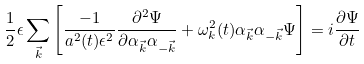<formula> <loc_0><loc_0><loc_500><loc_500>\frac { 1 } { 2 } \epsilon \sum _ { \vec { k } } { \left [ \frac { - 1 } { a ^ { 2 } ( t ) \epsilon ^ { 2 } } \frac { \partial ^ { 2 } \Psi } { \partial \alpha _ { \vec { k } } \alpha _ { - \vec { k } } } + \omega _ { k } ^ { 2 } ( t ) \alpha _ { \vec { k } } \alpha _ { - \vec { k } } \Psi \right ] } = i \frac { \partial \Psi } { \partial t }</formula> 